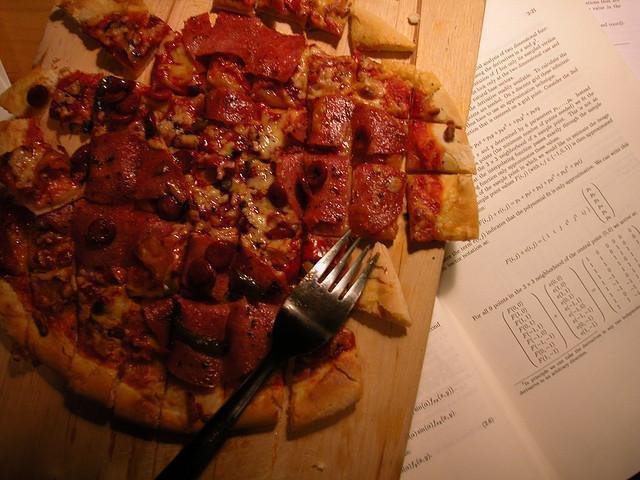How many kites are in the air?
Give a very brief answer. 0. 